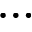<formula> <loc_0><loc_0><loc_500><loc_500>\dots</formula> 